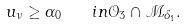<formula> <loc_0><loc_0><loc_500><loc_500>u _ { \nu } \geq \alpha _ { 0 } \quad i n { \mathcal { O } } _ { 3 } \cap { \mathcal { M } } _ { \delta _ { 1 } } .</formula> 